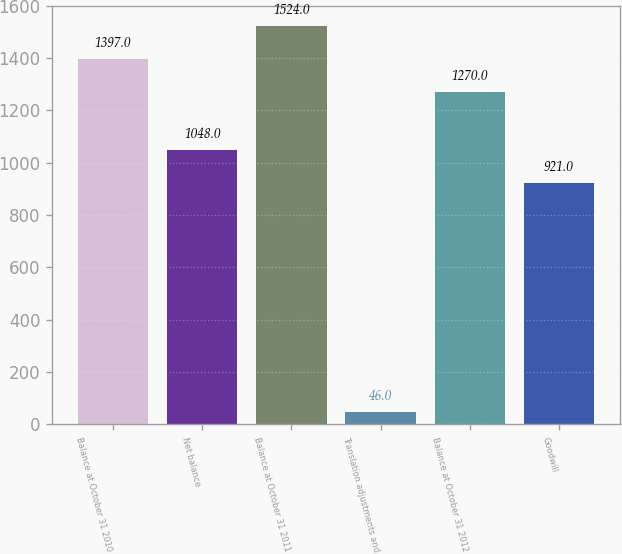Convert chart to OTSL. <chart><loc_0><loc_0><loc_500><loc_500><bar_chart><fcel>Balance at October 31 2010<fcel>Net balance<fcel>Balance at October 31 2011<fcel>Translation adjustments and<fcel>Balance at October 31 2012<fcel>Goodwill<nl><fcel>1397<fcel>1048<fcel>1524<fcel>46<fcel>1270<fcel>921<nl></chart> 